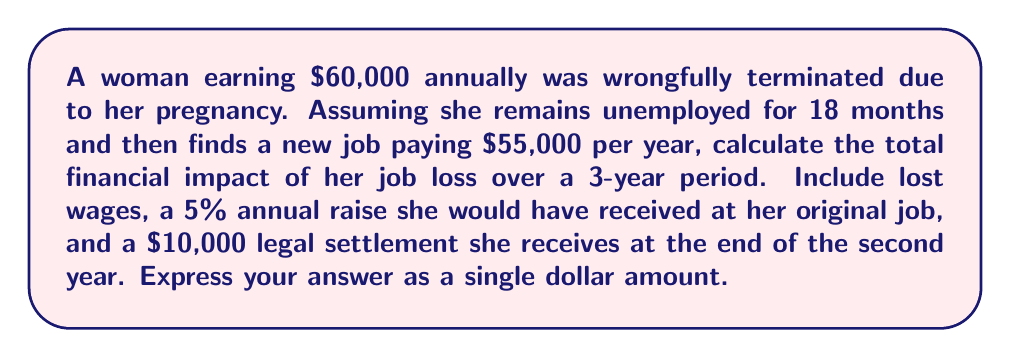Can you solve this math problem? Let's break this down step-by-step:

1. Calculate the lost wages for the 18 months of unemployment:
   $$\frac{60,000}{12} \times 18 = 90,000$$

2. Calculate what she would have earned in her original job over 3 years with 5% annual raises:
   Year 1: $60,000
   Year 2: $60,000 \times 1.05 = $63,000
   Year 3: $63,000 \times 1.05 = $66,150
   Total: $60,000 + $63,000 + $66,150 = $189,150

3. Calculate what she actually earns in the new job for the remaining 18 months:
   $$\frac{55,000}{12} \times 18 = 82,500$$

4. Subtract the new job earnings from what she would have earned:
   $$189,150 - 82,500 = 106,650$$

5. Subtract the $10,000 legal settlement:
   $$106,650 - 10,000 = 96,650$$

Therefore, the total financial impact over the 3-year period is $96,650.
Answer: $96,650 